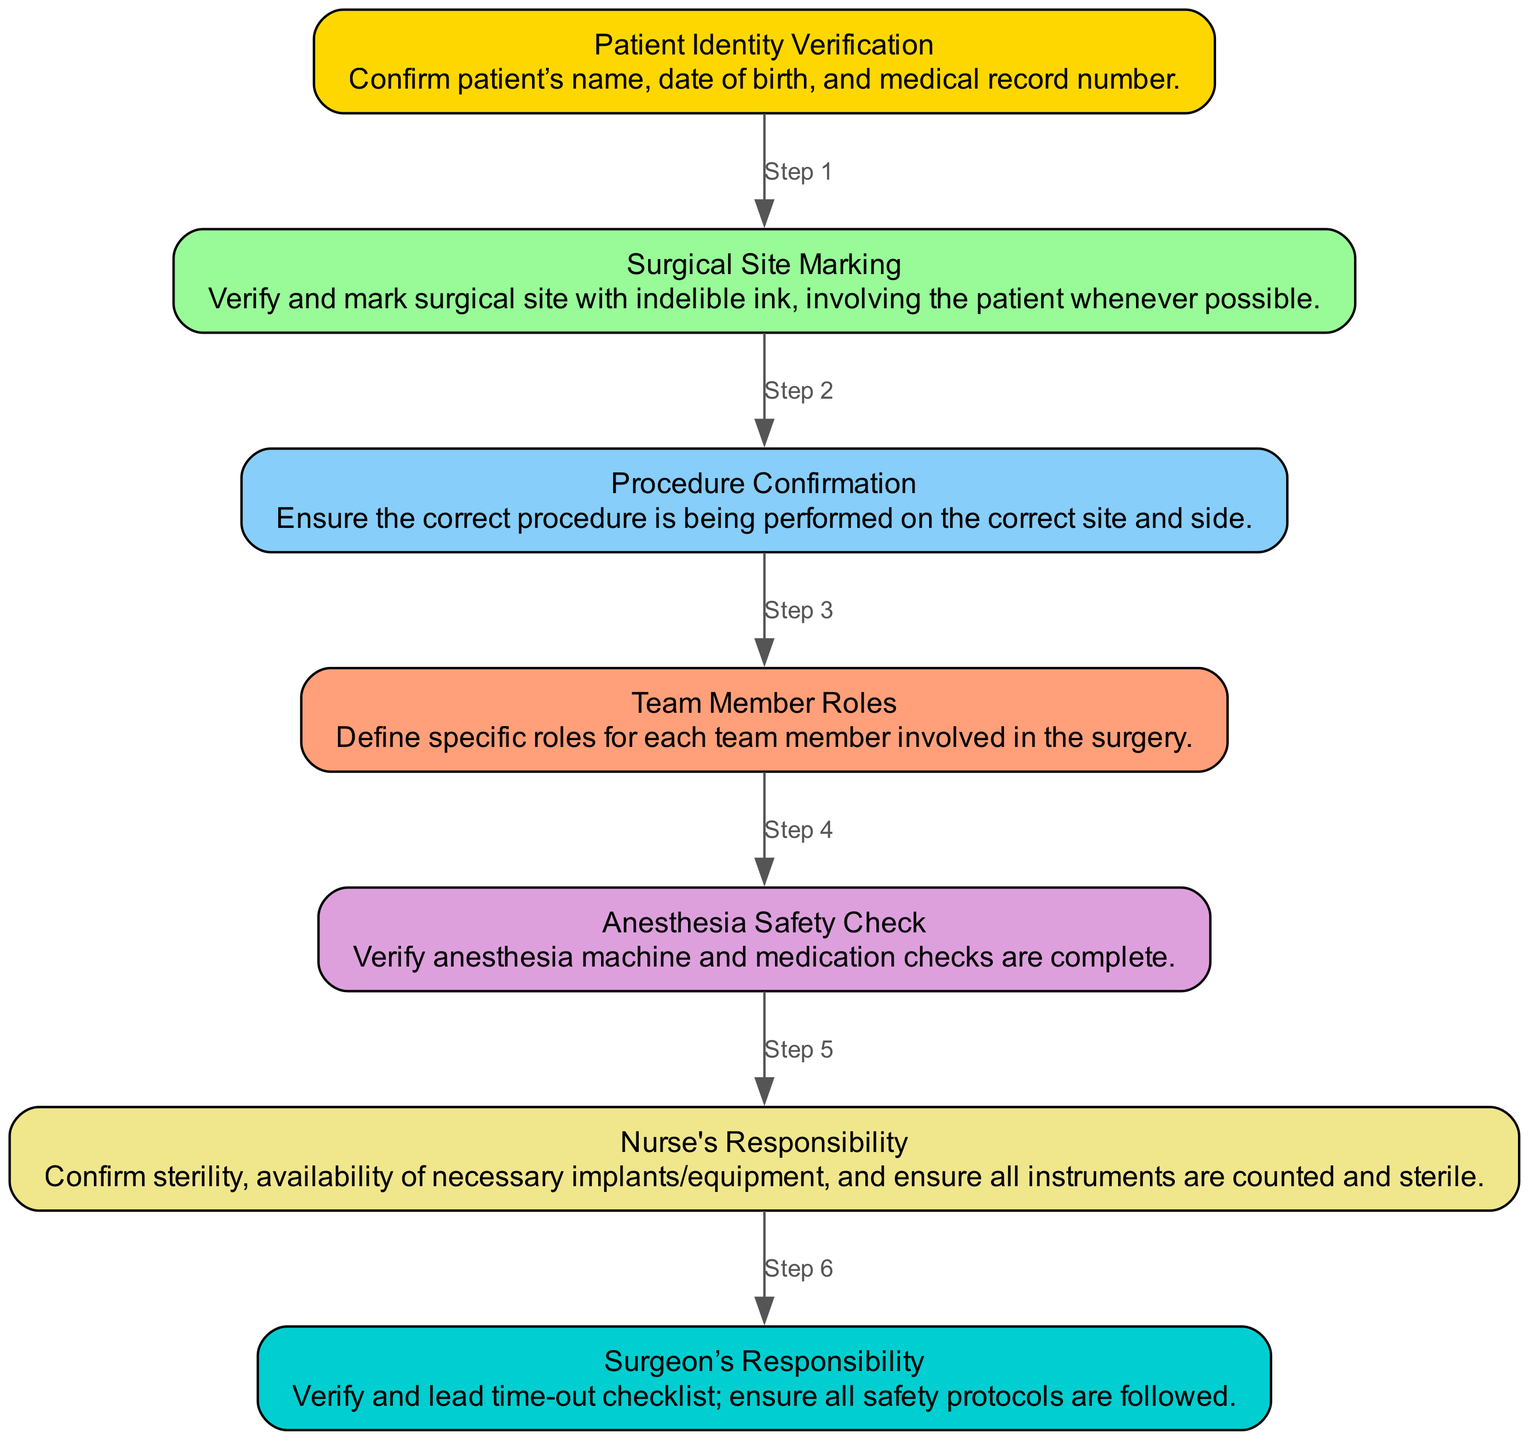What is the first step in the surgical time-out checklist? The first step outlined in the diagram is "Patient Identity Verification," which involves confirming the patient's name, date of birth, and medical record number.
Answer: Patient Identity Verification How many nodes are there in the diagram? The diagram contains 7 nodes, each representing different components of the surgical time-out and safety checklist.
Answer: 7 What step follows "Surgical Site Marking"? According to the flow of the diagram, "Procedure Confirmation" follows "Surgical Site Marking." This step ensures the correct procedure is performed on the correct site and side.
Answer: Procedure Confirmation Who is responsible for leading the time-out checklist? The "Surgeon’s Responsibility" node states it is the surgeon who verifies and leads the time-out checklist.
Answer: Surgeon What is the purpose of the "Anesthesia Safety Check"? The "Anesthesia Safety Check" ensures that the anesthesia machine and medication checks are completed, confirming that everything is set up properly before surgery.
Answer: Verify anesthesia safety What color is used for the "Nurse's Responsibility" in the diagram? The node representing "Nurse's Responsibility" is colored Khaki, which is the designated color for this role in the diagram.
Answer: Khaki How does the diagram ensure patient involvement in surgical site marking? The diagram emphasizes "Surgical Site Marking" involves the patient whenever possible, reinforcing the importance of patient participation in this critical verification step.
Answer: Involving the patient What is the last step before the surgeon's responsibility? Prior to the "Surgeon’s Responsibility," the last step described in the flow is the "Nurse's Responsibility," which includes confirming sterility, availability of necessary implants, equipment, and ensuring all instruments are counted and sterile.
Answer: Nurse's Responsibility What color represents the "Procedure Confirmation" step? The "Procedure Confirmation" step in the diagram is represented by Light Sky Blue color.
Answer: Light Sky Blue 